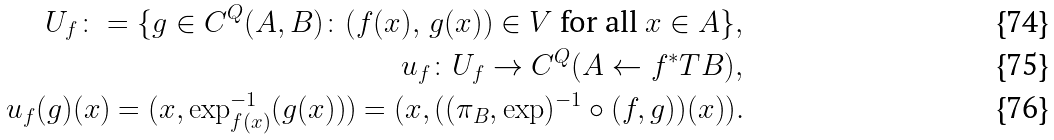Convert formula to latex. <formula><loc_0><loc_0><loc_500><loc_500>U _ { f } \colon = \{ g \in C ^ { Q } ( A , B ) \colon ( f ( x ) , \, g ( x ) ) \in V \text { for all } x \in A \} , \\ u _ { f } \colon U _ { f } \to C ^ { Q } ( A \gets f ^ { * } T B ) , \\ u _ { f } ( g ) ( x ) = ( x , \exp _ { f ( x ) } ^ { - 1 } ( g ( x ) ) ) = ( x , ( ( \pi _ { B } , \exp ) ^ { - 1 } \circ ( f , g ) ) ( x ) ) .</formula> 